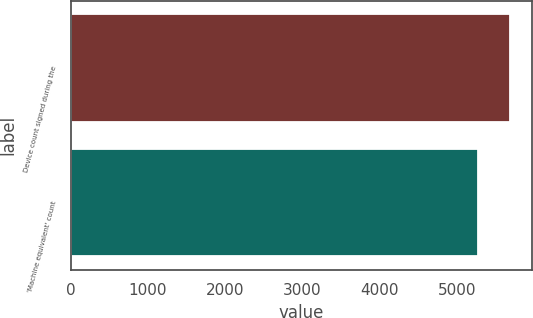<chart> <loc_0><loc_0><loc_500><loc_500><bar_chart><fcel>Device count signed during the<fcel>'Machine equivalent' count<nl><fcel>5679<fcel>5271<nl></chart> 